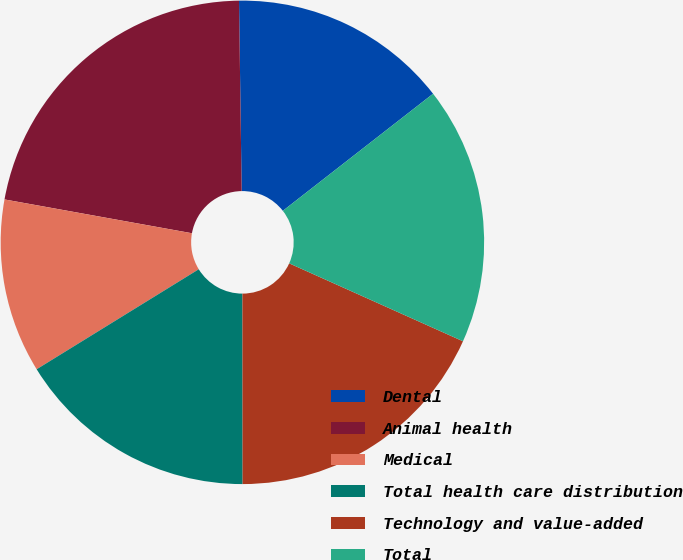Convert chart to OTSL. <chart><loc_0><loc_0><loc_500><loc_500><pie_chart><fcel>Dental<fcel>Animal health<fcel>Medical<fcel>Total health care distribution<fcel>Technology and value-added<fcel>Total<nl><fcel>14.69%<fcel>21.94%<fcel>11.64%<fcel>16.22%<fcel>18.28%<fcel>17.25%<nl></chart> 